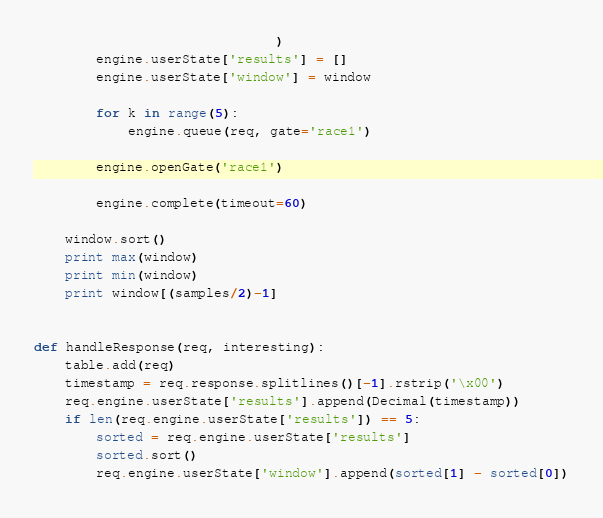Convert code to text. <code><loc_0><loc_0><loc_500><loc_500><_Python_>                               )
        engine.userState['results'] = []
        engine.userState['window'] = window

        for k in range(5):
            engine.queue(req, gate='race1')

        engine.openGate('race1')

        engine.complete(timeout=60)

    window.sort()
    print max(window)
    print min(window)
    print window[(samples/2)-1]


def handleResponse(req, interesting):
    table.add(req)
    timestamp = req.response.splitlines()[-1].rstrip('\x00')
    req.engine.userState['results'].append(Decimal(timestamp))
    if len(req.engine.userState['results']) == 5:
        sorted = req.engine.userState['results']
        sorted.sort()
        req.engine.userState['window'].append(sorted[1] - sorted[0])
</code> 